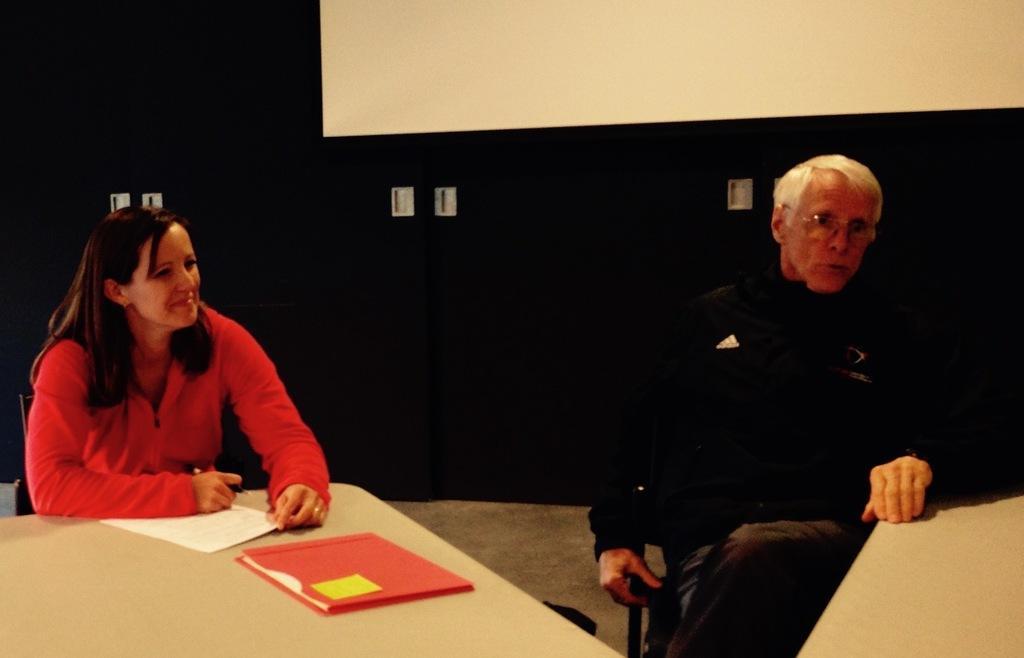Describe this image in one or two sentences. Bottom right side of the image a man is sitting on a chair. Bottom left side of the image there is a table, On the table there are some papers. Behind the table a woman is sitting on a chair and she is smiling. At the top of the image there is a screen. 